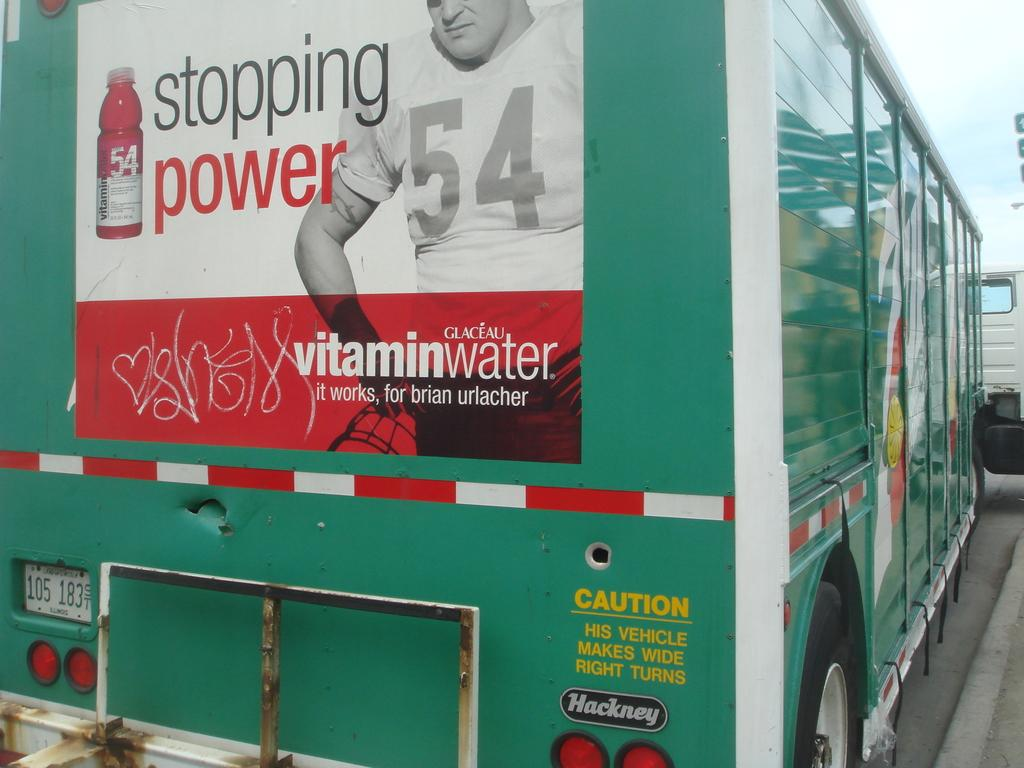What is on the vehicle in the image? There is a poster on a vehicle in the image. What can be seen in the background of the image? The sky is visible behind the vehicle. Are there any other vehicles in the image? Yes, there appears to be another vehicle on the right side of the image. How many clocks are hanging on the wall in the image? There are no clocks visible in the image; it features a poster on a vehicle and another vehicle on the right side. Can you see a kitten playing on the hood of the vehicle in the image? There is no kitten present in the image. 